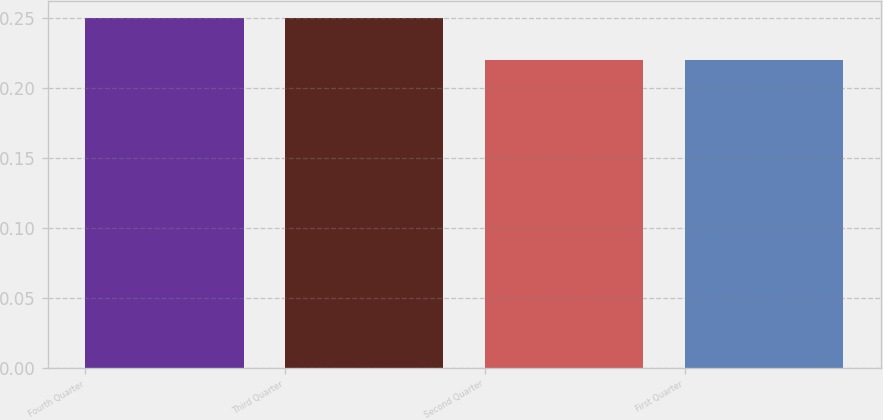<chart> <loc_0><loc_0><loc_500><loc_500><bar_chart><fcel>Fourth Quarter<fcel>Third Quarter<fcel>Second Quarter<fcel>First Quarter<nl><fcel>0.25<fcel>0.25<fcel>0.22<fcel>0.22<nl></chart> 